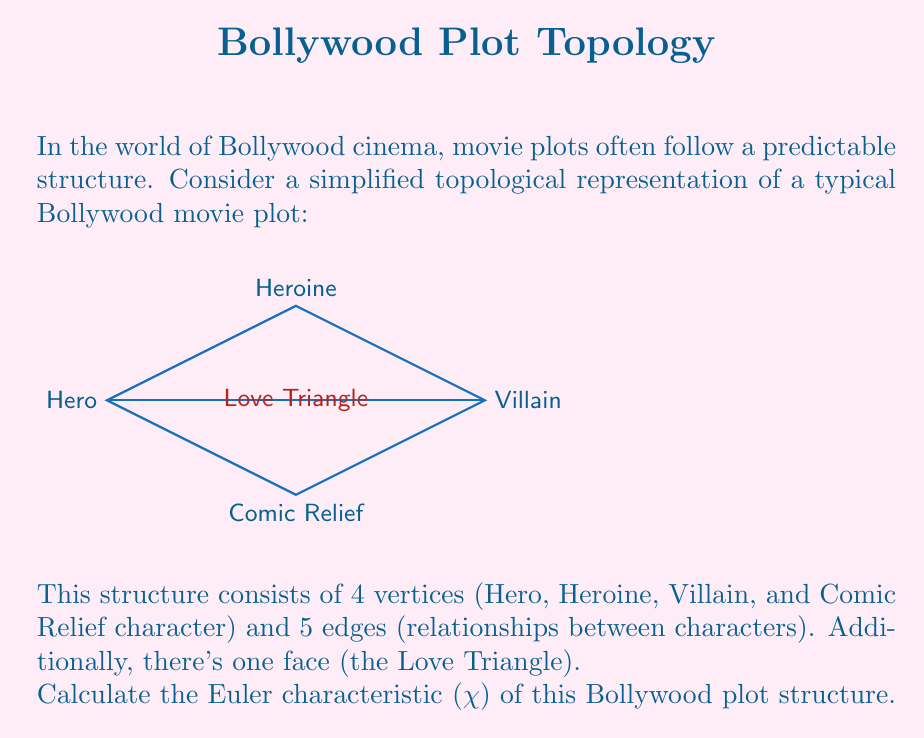Provide a solution to this math problem. To calculate the Euler characteristic (χ) of this topological structure, we'll use the formula:

$$ χ = V - E + F $$

Where:
- $V$ is the number of vertices
- $E$ is the number of edges
- $F$ is the number of faces

Let's identify each component:

1. Vertices (V):
   We have 4 vertices representing the main characters:
   - Hero
   - Heroine
   - Villain
   - Comic Relief
   Therefore, $V = 4$

2. Edges (E):
   There are 5 edges representing relationships:
   - Hero -- Heroine
   - Hero -- Villain
   - Heroine -- Villain
   - Hero -- Comic Relief
   - Villain -- Comic Relief
   So, $E = 5$

3. Faces (F):
   We have 1 face (the Love Triangle) plus the outer face (which is always counted in planar graphs).
   Therefore, $F = 2$

Now, let's substitute these values into the Euler characteristic formula:

$$ χ = V - E + F $$
$$ χ = 4 - 5 + 2 $$
$$ χ = 1 $$

The Euler characteristic of this Bollywood plot structure is 1, which is consistent with the fact that it's a planar graph (can be drawn on a plane without edge crossings).
Answer: $χ = 1$ 